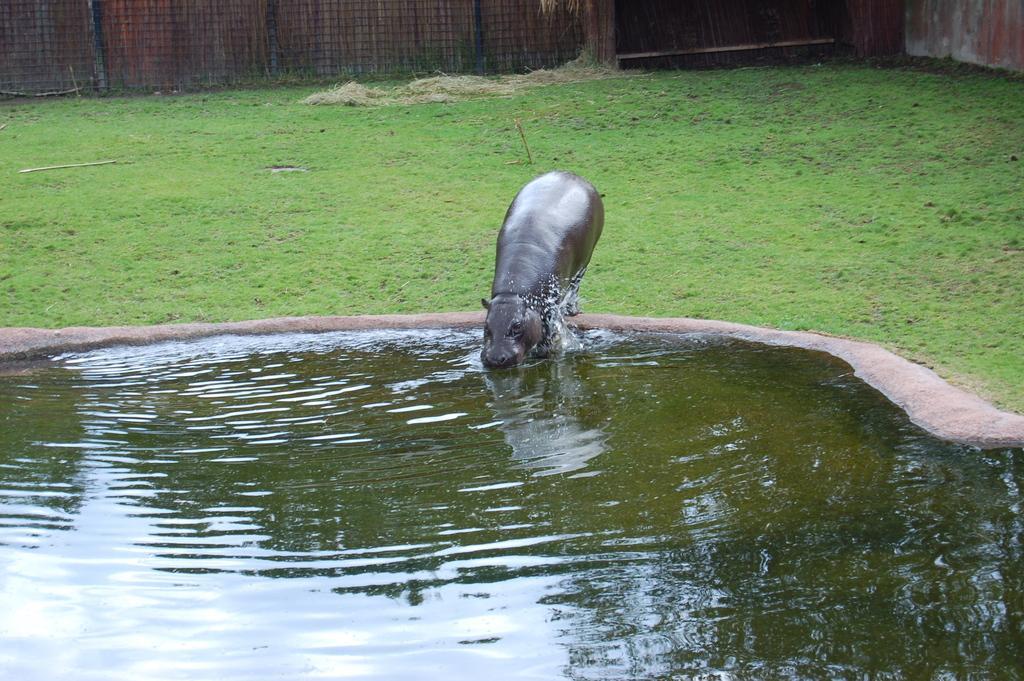Please provide a concise description of this image. In this image we can see a hippopotamus beside a pond. On the backside we can see some grass, a wooden wall and a fence. 